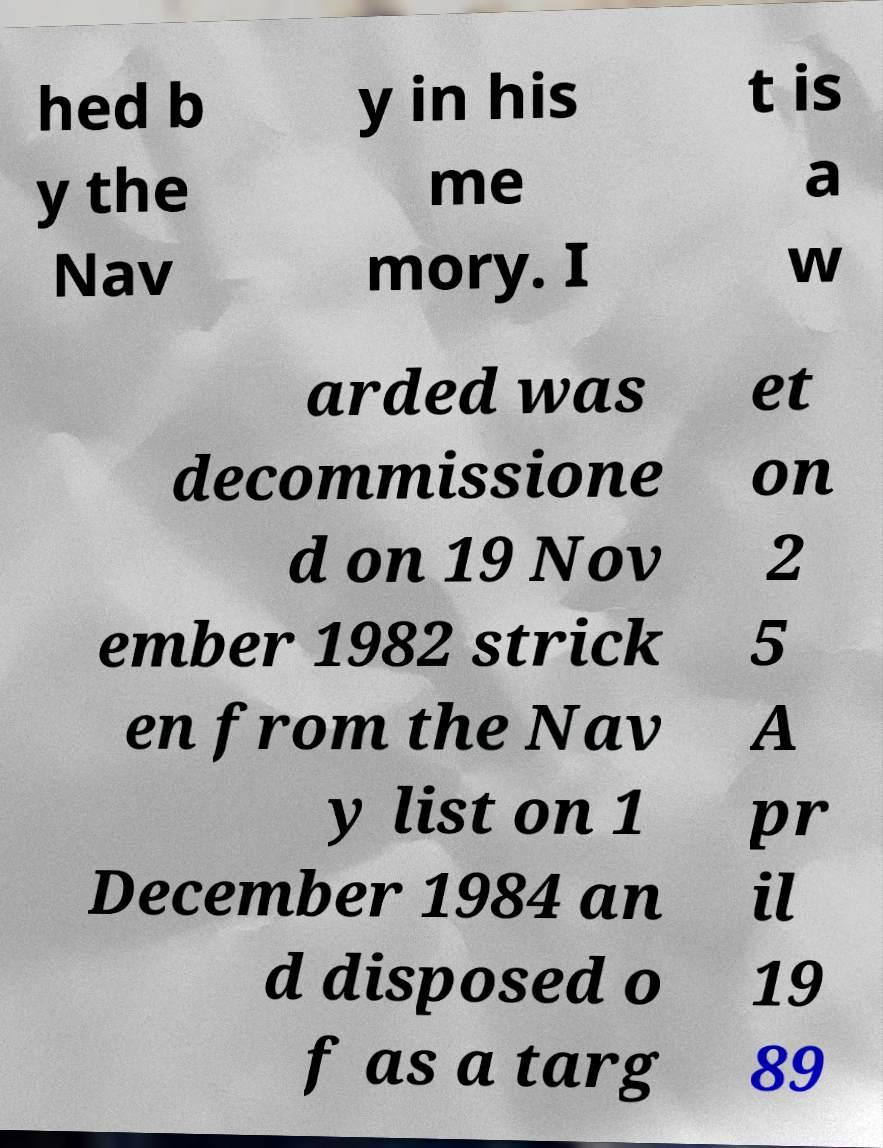Can you accurately transcribe the text from the provided image for me? hed b y the Nav y in his me mory. I t is a w arded was decommissione d on 19 Nov ember 1982 strick en from the Nav y list on 1 December 1984 an d disposed o f as a targ et on 2 5 A pr il 19 89 